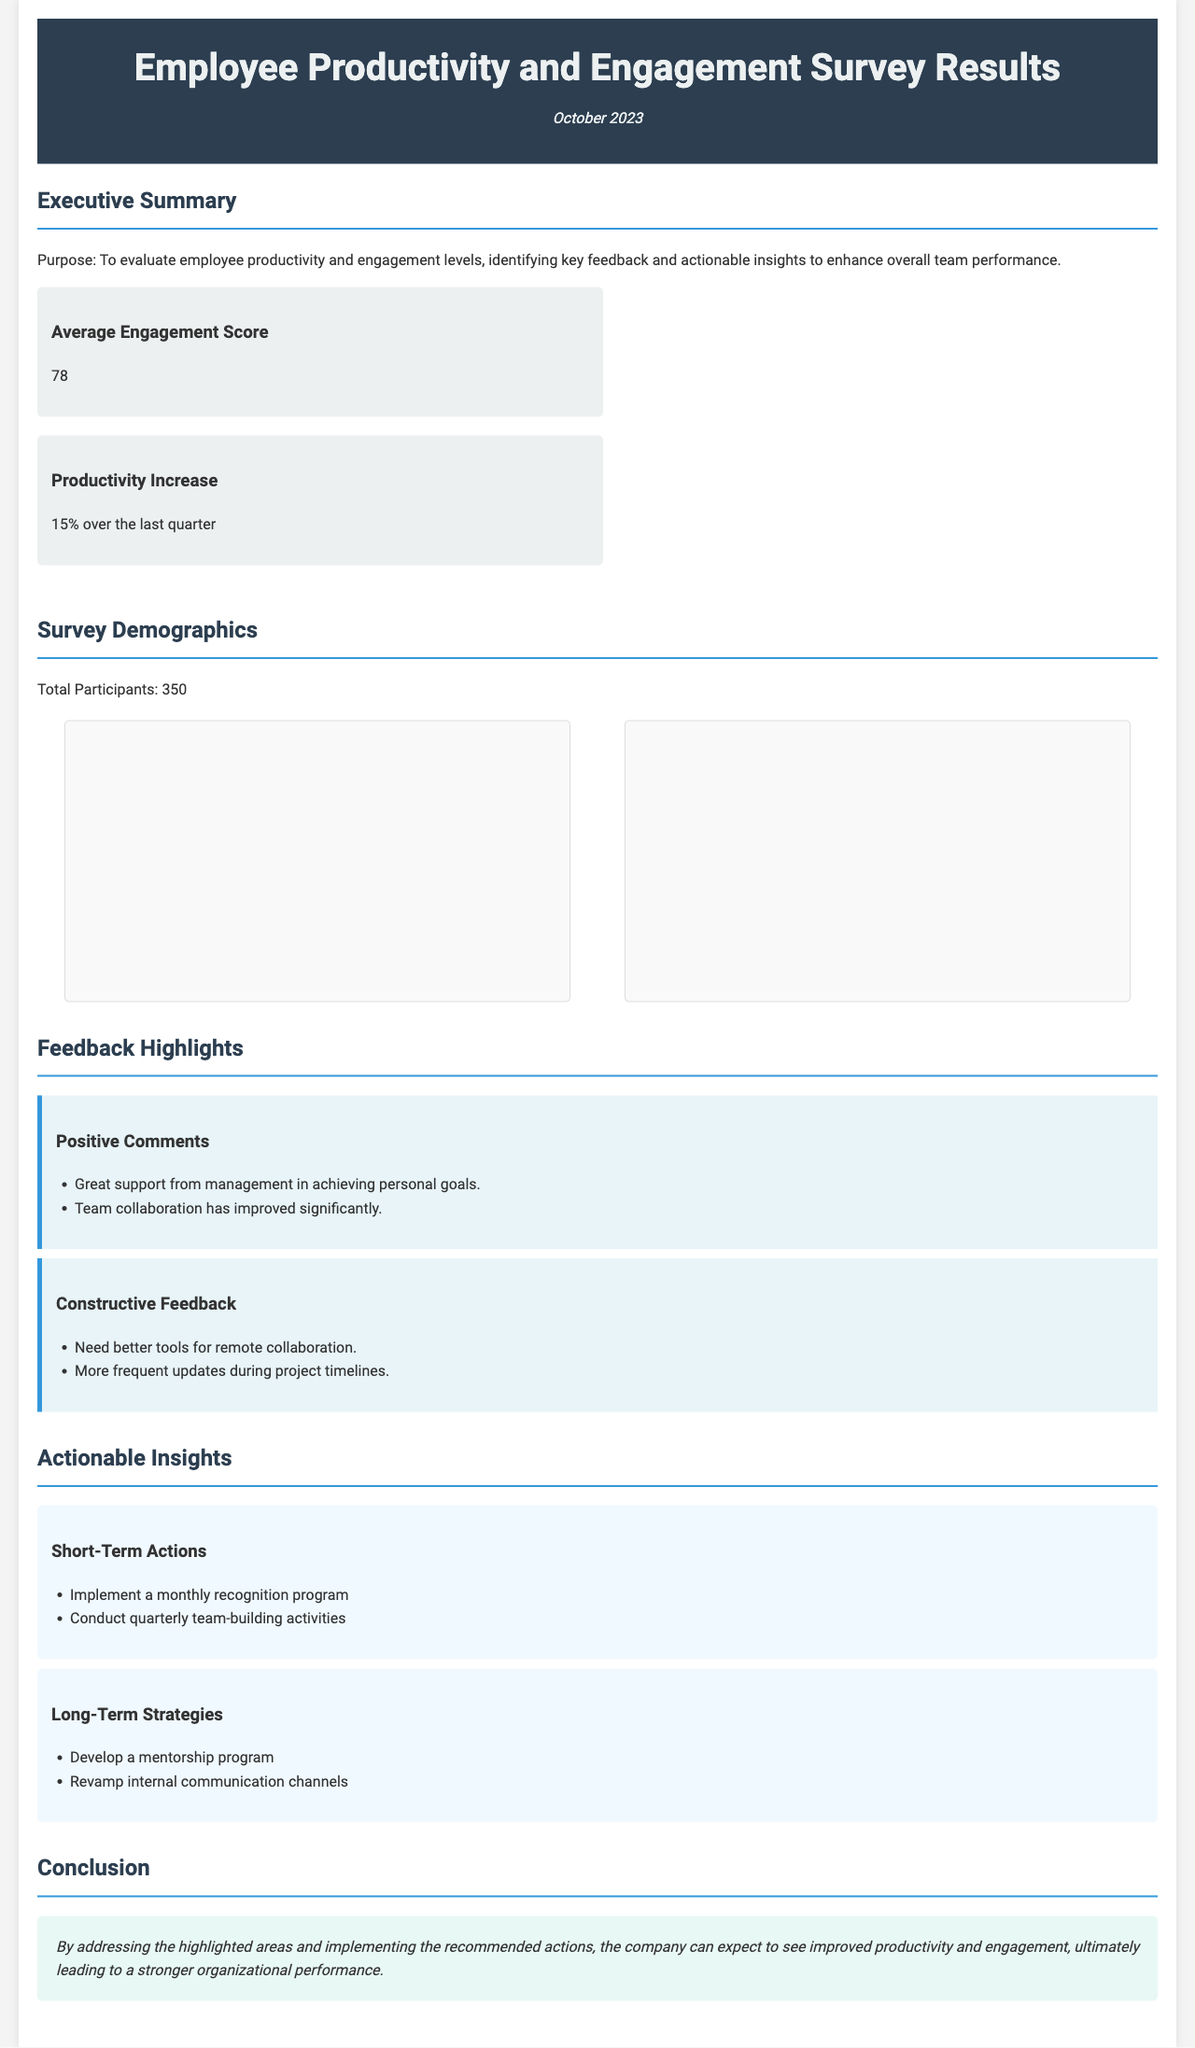What is the average engagement score? The average engagement score is stated in the executive summary as a key finding.
Answer: 78 What was the productivity increase over the last quarter? The productivity increase is noted in the executive summary.
Answer: 15% How many total participants were in the survey? The total number of participants is mentioned in the section about survey demographics.
Answer: 350 What are the two positive comments highlighted in the feedback section? The feedback section contains a list of positive comments from participants.
Answer: Great support from management in achieving personal goals; Team collaboration has improved significantly What is one of the short-term actions recommended? The action items include short-term actions to improve engagement and productivity, listed in the actionable insights section.
Answer: Implement a monthly recognition program Which department has the highest number of participants? The department breakdown chart provides information about the distribution of participants across departments.
Answer: Sales What are the top three engagement drivers according to the survey? The engagement drivers are displayed in the engagement drivers chart, summarizing key factors influencing engagement.
Answer: Recognition, Career Advancement, Work-life Balance What type of document is this? The structure and content suggest that this is a report evaluating employee productivity and engagement.
Answer: Survey Results Report What conclusion does the report highlight regarding the implementation of recommended actions? The conclusion section summarizes the expected outcomes from addressing highlighted areas and implementing actions.
Answer: Improved productivity and engagement 